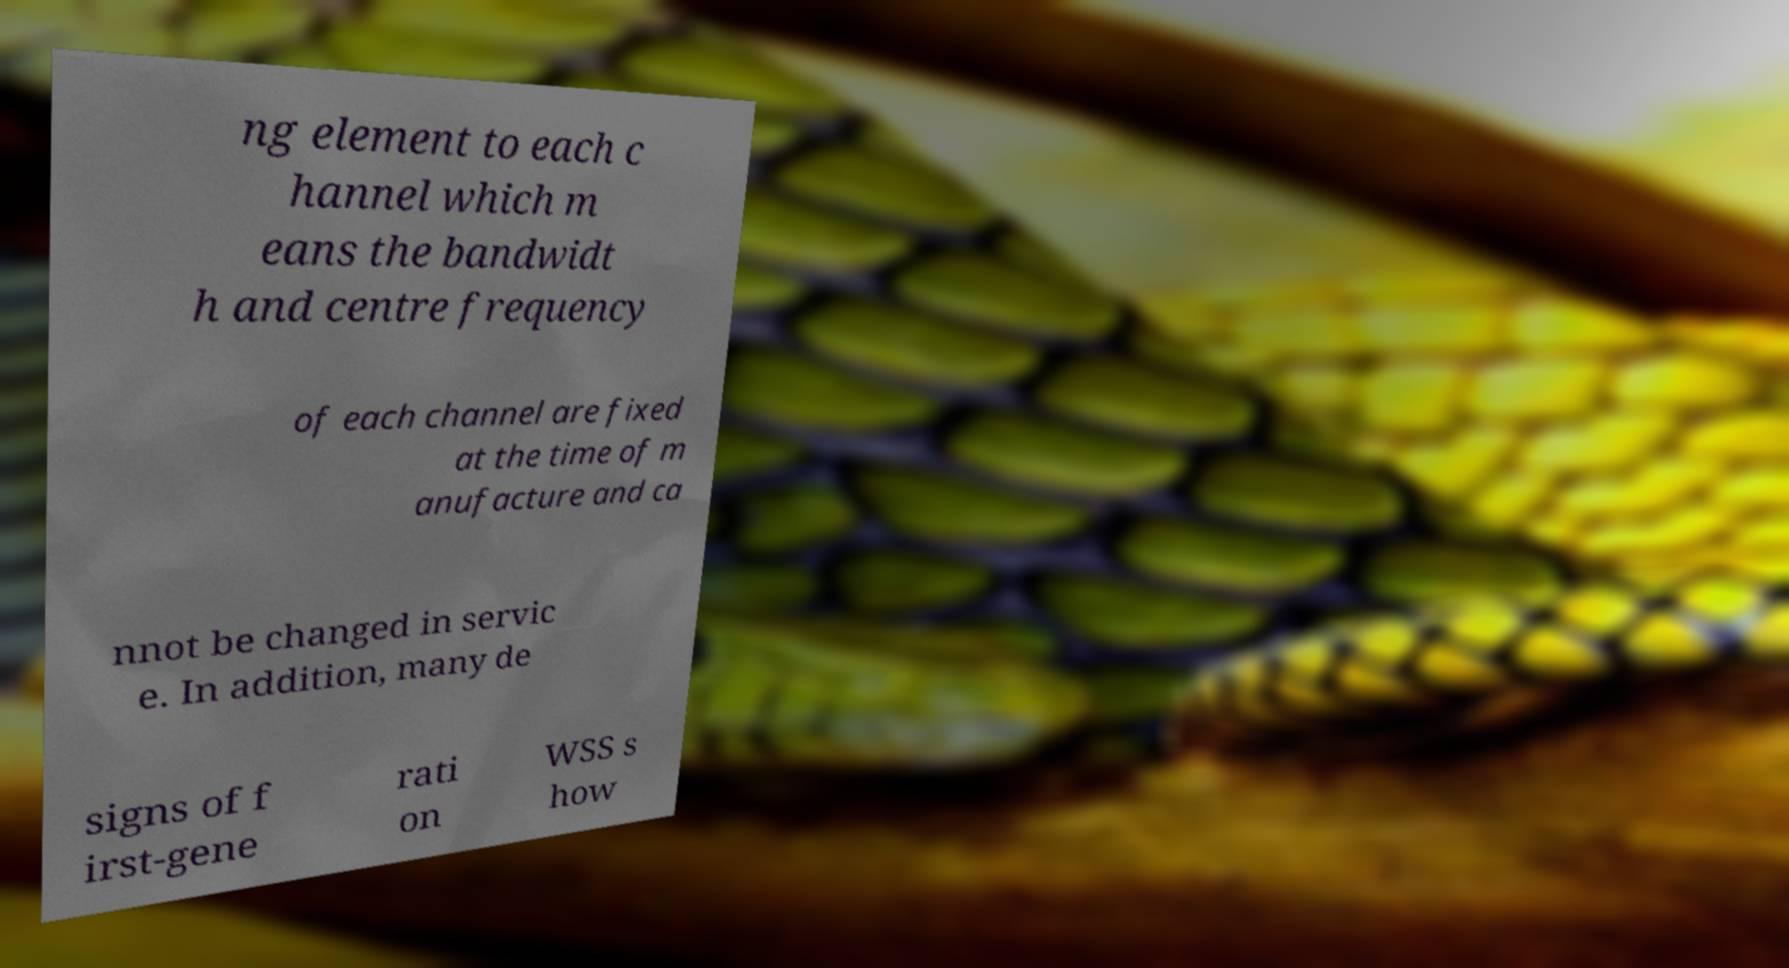Could you assist in decoding the text presented in this image and type it out clearly? ng element to each c hannel which m eans the bandwidt h and centre frequency of each channel are fixed at the time of m anufacture and ca nnot be changed in servic e. In addition, many de signs of f irst-gene rati on WSS s how 